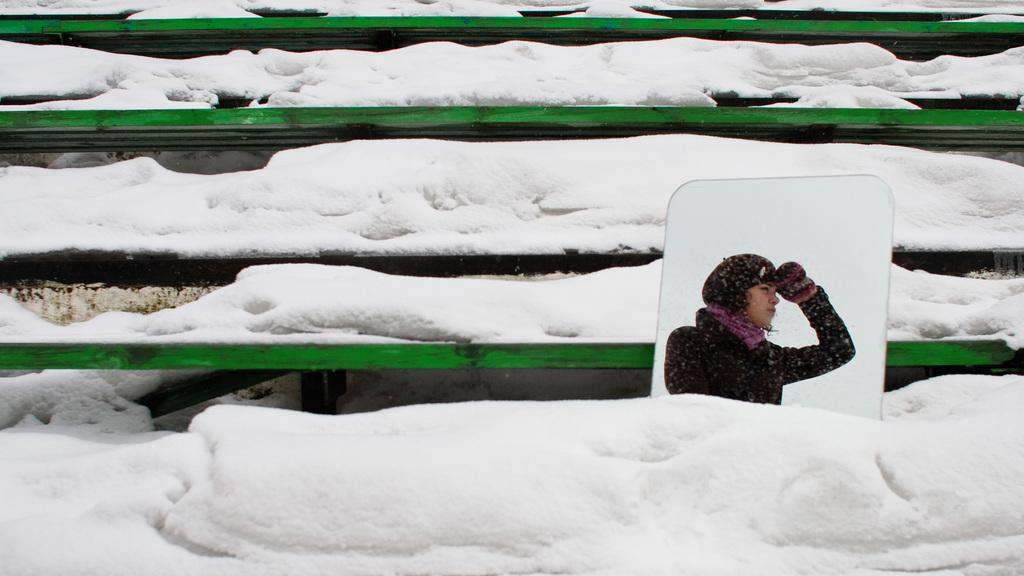What is located in the foreground of the image? There is a mirror in the foreground of the image. Who or what can be seen in the mirror? A woman is visible in the mirror. What is the ground made of around the mirror? There is snow around the mirror. What type of seating is present in the image? There appear to be green benches in the image. What type of sink is visible in the image? There is no sink present in the image. How does the woman in the mirror cough in the image? The woman in the mirror is not coughing in the image; she is simply visible in the reflection. 